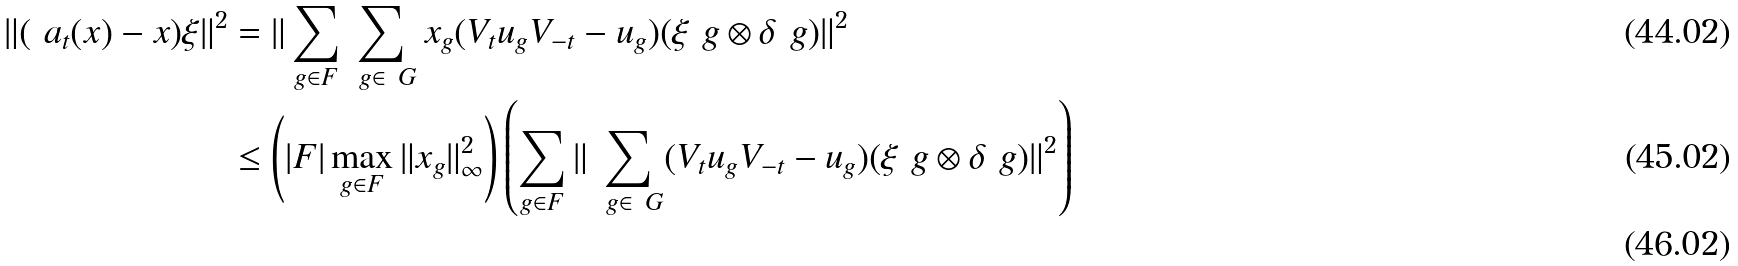<formula> <loc_0><loc_0><loc_500><loc_500>\| ( \ a _ { t } ( x ) - x ) \xi \| ^ { 2 } & = \| \sum _ { g \in F } \sum _ { \ g \in \ G } x _ { g } ( V _ { t } u _ { g } V _ { - t } - u _ { g } ) ( \xi _ { \ } g \otimes \delta _ { \ } g ) \| ^ { 2 } \\ & \leq \left ( | F | \max _ { g \in F } \| x _ { g } \| ^ { 2 } _ { \infty } \right ) \left ( \sum _ { g \in F } \| \sum _ { \ g \in \ G } ( V _ { t } u _ { g } V _ { - t } - u _ { g } ) ( \xi _ { \ } g \otimes \delta _ { \ } g ) \| ^ { 2 } \right ) \\</formula> 